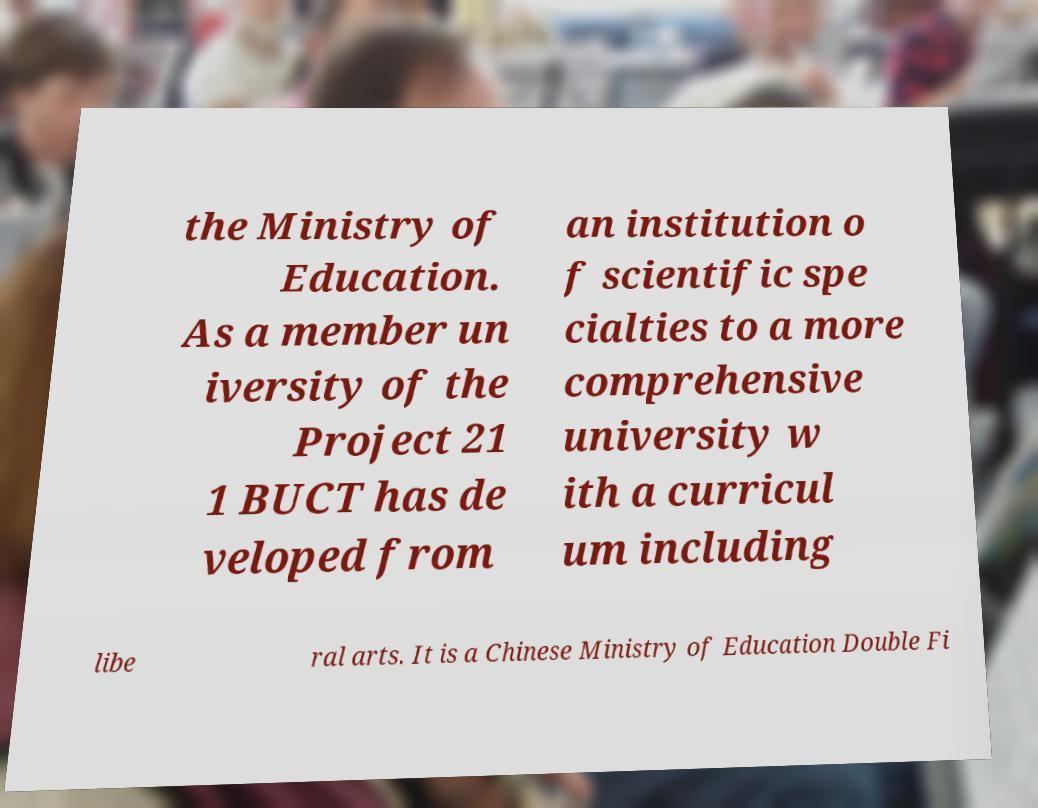What messages or text are displayed in this image? I need them in a readable, typed format. the Ministry of Education. As a member un iversity of the Project 21 1 BUCT has de veloped from an institution o f scientific spe cialties to a more comprehensive university w ith a curricul um including libe ral arts. It is a Chinese Ministry of Education Double Fi 